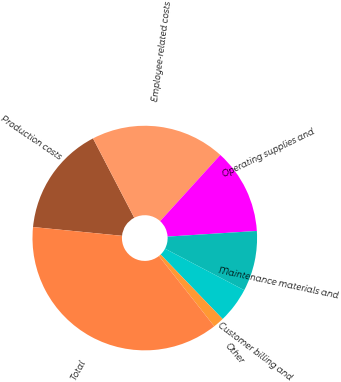Convert chart to OTSL. <chart><loc_0><loc_0><loc_500><loc_500><pie_chart><fcel>Production costs<fcel>Employee-related costs<fcel>Operating supplies and<fcel>Maintenance materials and<fcel>Customer billing and<fcel>Other<fcel>Total<nl><fcel>15.81%<fcel>19.37%<fcel>12.25%<fcel>8.69%<fcel>5.13%<fcel>1.57%<fcel>37.18%<nl></chart> 